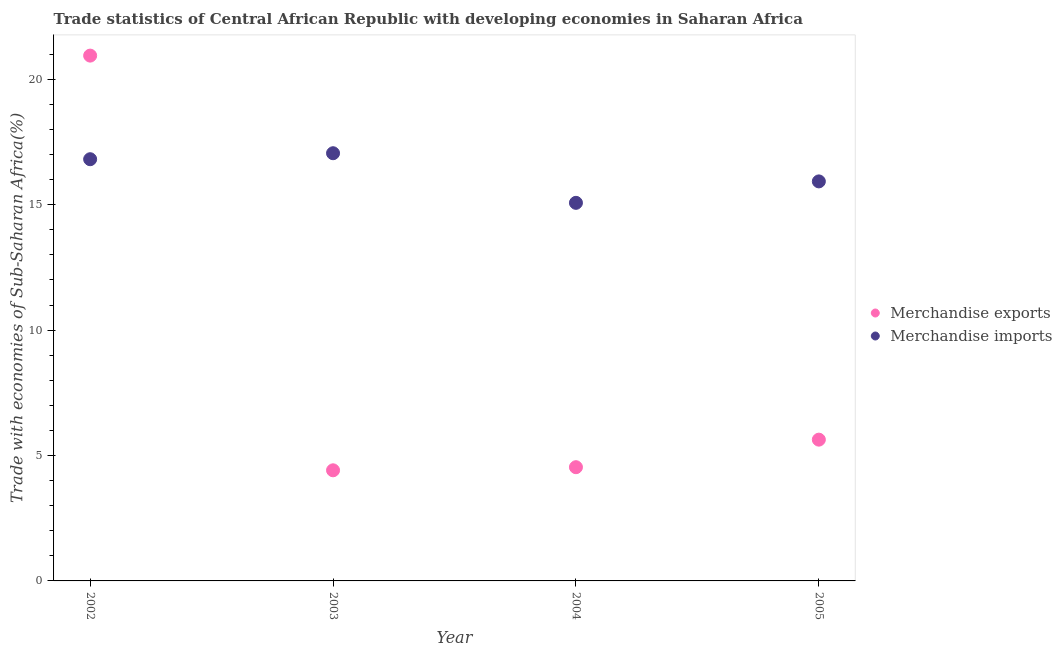Is the number of dotlines equal to the number of legend labels?
Keep it short and to the point. Yes. What is the merchandise imports in 2004?
Your response must be concise. 15.07. Across all years, what is the maximum merchandise exports?
Provide a succinct answer. 20.94. Across all years, what is the minimum merchandise exports?
Offer a very short reply. 4.41. In which year was the merchandise exports maximum?
Offer a very short reply. 2002. In which year was the merchandise imports minimum?
Provide a succinct answer. 2004. What is the total merchandise imports in the graph?
Keep it short and to the point. 64.87. What is the difference between the merchandise exports in 2002 and that in 2003?
Make the answer very short. 16.53. What is the difference between the merchandise imports in 2002 and the merchandise exports in 2005?
Give a very brief answer. 11.18. What is the average merchandise imports per year?
Offer a terse response. 16.22. In the year 2004, what is the difference between the merchandise exports and merchandise imports?
Provide a short and direct response. -10.54. In how many years, is the merchandise imports greater than 15 %?
Your response must be concise. 4. What is the ratio of the merchandise exports in 2002 to that in 2005?
Offer a terse response. 3.72. What is the difference between the highest and the second highest merchandise imports?
Provide a succinct answer. 0.24. What is the difference between the highest and the lowest merchandise imports?
Make the answer very short. 1.98. Is the sum of the merchandise imports in 2002 and 2004 greater than the maximum merchandise exports across all years?
Your answer should be very brief. Yes. Does the merchandise imports monotonically increase over the years?
Your response must be concise. No. How many years are there in the graph?
Your answer should be compact. 4. What is the difference between two consecutive major ticks on the Y-axis?
Your response must be concise. 5. Where does the legend appear in the graph?
Make the answer very short. Center right. How are the legend labels stacked?
Your response must be concise. Vertical. What is the title of the graph?
Provide a short and direct response. Trade statistics of Central African Republic with developing economies in Saharan Africa. What is the label or title of the X-axis?
Provide a short and direct response. Year. What is the label or title of the Y-axis?
Your answer should be compact. Trade with economies of Sub-Saharan Africa(%). What is the Trade with economies of Sub-Saharan Africa(%) in Merchandise exports in 2002?
Your answer should be compact. 20.94. What is the Trade with economies of Sub-Saharan Africa(%) in Merchandise imports in 2002?
Keep it short and to the point. 16.81. What is the Trade with economies of Sub-Saharan Africa(%) in Merchandise exports in 2003?
Provide a short and direct response. 4.41. What is the Trade with economies of Sub-Saharan Africa(%) of Merchandise imports in 2003?
Your answer should be very brief. 17.05. What is the Trade with economies of Sub-Saharan Africa(%) in Merchandise exports in 2004?
Provide a succinct answer. 4.53. What is the Trade with economies of Sub-Saharan Africa(%) of Merchandise imports in 2004?
Your answer should be compact. 15.07. What is the Trade with economies of Sub-Saharan Africa(%) in Merchandise exports in 2005?
Offer a very short reply. 5.63. What is the Trade with economies of Sub-Saharan Africa(%) in Merchandise imports in 2005?
Ensure brevity in your answer.  15.93. Across all years, what is the maximum Trade with economies of Sub-Saharan Africa(%) in Merchandise exports?
Make the answer very short. 20.94. Across all years, what is the maximum Trade with economies of Sub-Saharan Africa(%) in Merchandise imports?
Make the answer very short. 17.05. Across all years, what is the minimum Trade with economies of Sub-Saharan Africa(%) of Merchandise exports?
Your answer should be very brief. 4.41. Across all years, what is the minimum Trade with economies of Sub-Saharan Africa(%) of Merchandise imports?
Ensure brevity in your answer.  15.07. What is the total Trade with economies of Sub-Saharan Africa(%) in Merchandise exports in the graph?
Keep it short and to the point. 35.52. What is the total Trade with economies of Sub-Saharan Africa(%) in Merchandise imports in the graph?
Keep it short and to the point. 64.87. What is the difference between the Trade with economies of Sub-Saharan Africa(%) of Merchandise exports in 2002 and that in 2003?
Your response must be concise. 16.53. What is the difference between the Trade with economies of Sub-Saharan Africa(%) in Merchandise imports in 2002 and that in 2003?
Ensure brevity in your answer.  -0.24. What is the difference between the Trade with economies of Sub-Saharan Africa(%) in Merchandise exports in 2002 and that in 2004?
Keep it short and to the point. 16.41. What is the difference between the Trade with economies of Sub-Saharan Africa(%) of Merchandise imports in 2002 and that in 2004?
Your response must be concise. 1.74. What is the difference between the Trade with economies of Sub-Saharan Africa(%) in Merchandise exports in 2002 and that in 2005?
Make the answer very short. 15.31. What is the difference between the Trade with economies of Sub-Saharan Africa(%) in Merchandise imports in 2002 and that in 2005?
Ensure brevity in your answer.  0.88. What is the difference between the Trade with economies of Sub-Saharan Africa(%) in Merchandise exports in 2003 and that in 2004?
Your answer should be compact. -0.12. What is the difference between the Trade with economies of Sub-Saharan Africa(%) in Merchandise imports in 2003 and that in 2004?
Your response must be concise. 1.98. What is the difference between the Trade with economies of Sub-Saharan Africa(%) of Merchandise exports in 2003 and that in 2005?
Offer a very short reply. -1.22. What is the difference between the Trade with economies of Sub-Saharan Africa(%) in Merchandise imports in 2003 and that in 2005?
Give a very brief answer. 1.12. What is the difference between the Trade with economies of Sub-Saharan Africa(%) in Merchandise exports in 2004 and that in 2005?
Provide a succinct answer. -1.1. What is the difference between the Trade with economies of Sub-Saharan Africa(%) in Merchandise imports in 2004 and that in 2005?
Offer a very short reply. -0.85. What is the difference between the Trade with economies of Sub-Saharan Africa(%) of Merchandise exports in 2002 and the Trade with economies of Sub-Saharan Africa(%) of Merchandise imports in 2003?
Provide a short and direct response. 3.89. What is the difference between the Trade with economies of Sub-Saharan Africa(%) of Merchandise exports in 2002 and the Trade with economies of Sub-Saharan Africa(%) of Merchandise imports in 2004?
Keep it short and to the point. 5.87. What is the difference between the Trade with economies of Sub-Saharan Africa(%) of Merchandise exports in 2002 and the Trade with economies of Sub-Saharan Africa(%) of Merchandise imports in 2005?
Make the answer very short. 5.02. What is the difference between the Trade with economies of Sub-Saharan Africa(%) of Merchandise exports in 2003 and the Trade with economies of Sub-Saharan Africa(%) of Merchandise imports in 2004?
Offer a very short reply. -10.66. What is the difference between the Trade with economies of Sub-Saharan Africa(%) of Merchandise exports in 2003 and the Trade with economies of Sub-Saharan Africa(%) of Merchandise imports in 2005?
Offer a terse response. -11.52. What is the difference between the Trade with economies of Sub-Saharan Africa(%) of Merchandise exports in 2004 and the Trade with economies of Sub-Saharan Africa(%) of Merchandise imports in 2005?
Offer a very short reply. -11.39. What is the average Trade with economies of Sub-Saharan Africa(%) of Merchandise exports per year?
Give a very brief answer. 8.88. What is the average Trade with economies of Sub-Saharan Africa(%) of Merchandise imports per year?
Your answer should be very brief. 16.22. In the year 2002, what is the difference between the Trade with economies of Sub-Saharan Africa(%) in Merchandise exports and Trade with economies of Sub-Saharan Africa(%) in Merchandise imports?
Offer a very short reply. 4.13. In the year 2003, what is the difference between the Trade with economies of Sub-Saharan Africa(%) in Merchandise exports and Trade with economies of Sub-Saharan Africa(%) in Merchandise imports?
Keep it short and to the point. -12.64. In the year 2004, what is the difference between the Trade with economies of Sub-Saharan Africa(%) of Merchandise exports and Trade with economies of Sub-Saharan Africa(%) of Merchandise imports?
Your answer should be compact. -10.54. In the year 2005, what is the difference between the Trade with economies of Sub-Saharan Africa(%) of Merchandise exports and Trade with economies of Sub-Saharan Africa(%) of Merchandise imports?
Keep it short and to the point. -10.3. What is the ratio of the Trade with economies of Sub-Saharan Africa(%) in Merchandise exports in 2002 to that in 2003?
Your answer should be very brief. 4.75. What is the ratio of the Trade with economies of Sub-Saharan Africa(%) of Merchandise imports in 2002 to that in 2003?
Provide a short and direct response. 0.99. What is the ratio of the Trade with economies of Sub-Saharan Africa(%) in Merchandise exports in 2002 to that in 2004?
Make the answer very short. 4.62. What is the ratio of the Trade with economies of Sub-Saharan Africa(%) of Merchandise imports in 2002 to that in 2004?
Ensure brevity in your answer.  1.12. What is the ratio of the Trade with economies of Sub-Saharan Africa(%) of Merchandise exports in 2002 to that in 2005?
Offer a terse response. 3.72. What is the ratio of the Trade with economies of Sub-Saharan Africa(%) of Merchandise imports in 2002 to that in 2005?
Give a very brief answer. 1.06. What is the ratio of the Trade with economies of Sub-Saharan Africa(%) of Merchandise exports in 2003 to that in 2004?
Your answer should be very brief. 0.97. What is the ratio of the Trade with economies of Sub-Saharan Africa(%) of Merchandise imports in 2003 to that in 2004?
Your response must be concise. 1.13. What is the ratio of the Trade with economies of Sub-Saharan Africa(%) in Merchandise exports in 2003 to that in 2005?
Make the answer very short. 0.78. What is the ratio of the Trade with economies of Sub-Saharan Africa(%) of Merchandise imports in 2003 to that in 2005?
Your response must be concise. 1.07. What is the ratio of the Trade with economies of Sub-Saharan Africa(%) of Merchandise exports in 2004 to that in 2005?
Give a very brief answer. 0.81. What is the ratio of the Trade with economies of Sub-Saharan Africa(%) in Merchandise imports in 2004 to that in 2005?
Your answer should be very brief. 0.95. What is the difference between the highest and the second highest Trade with economies of Sub-Saharan Africa(%) of Merchandise exports?
Your response must be concise. 15.31. What is the difference between the highest and the second highest Trade with economies of Sub-Saharan Africa(%) in Merchandise imports?
Offer a very short reply. 0.24. What is the difference between the highest and the lowest Trade with economies of Sub-Saharan Africa(%) in Merchandise exports?
Your answer should be very brief. 16.53. What is the difference between the highest and the lowest Trade with economies of Sub-Saharan Africa(%) in Merchandise imports?
Your answer should be compact. 1.98. 